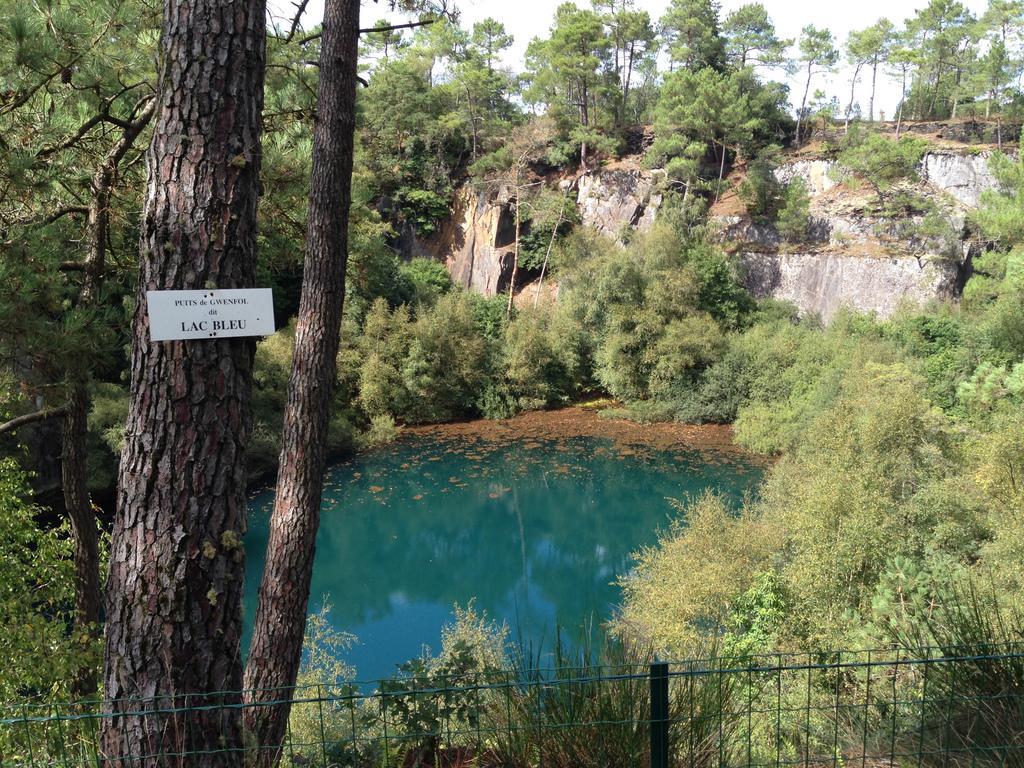Please provide a concise description of this image. In this picture I can see a board to the tree trunk, there are plants, trees, there is water, fence, and in the background there is the sky. 